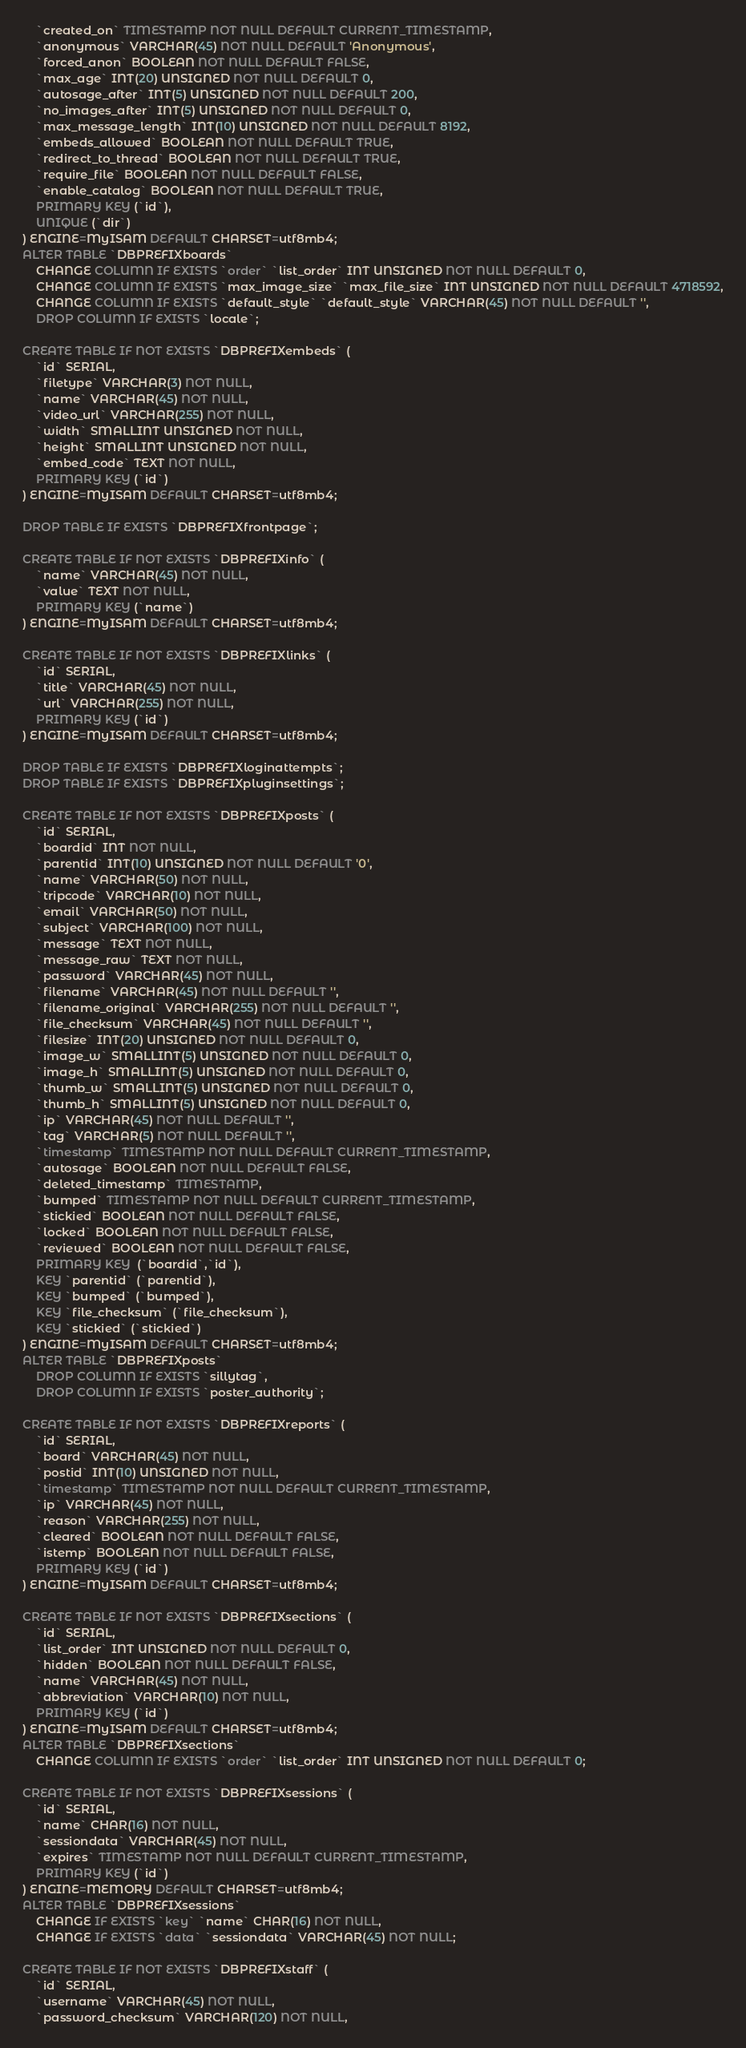Convert code to text. <code><loc_0><loc_0><loc_500><loc_500><_SQL_>	`created_on` TIMESTAMP NOT NULL DEFAULT CURRENT_TIMESTAMP,
	`anonymous` VARCHAR(45) NOT NULL DEFAULT 'Anonymous',
	`forced_anon` BOOLEAN NOT NULL DEFAULT FALSE,
	`max_age` INT(20) UNSIGNED NOT NULL DEFAULT 0,
	`autosage_after` INT(5) UNSIGNED NOT NULL DEFAULT 200,
	`no_images_after` INT(5) UNSIGNED NOT NULL DEFAULT 0,
	`max_message_length` INT(10) UNSIGNED NOT NULL DEFAULT 8192,
	`embeds_allowed` BOOLEAN NOT NULL DEFAULT TRUE,
	`redirect_to_thread` BOOLEAN NOT NULL DEFAULT TRUE,
	`require_file` BOOLEAN NOT NULL DEFAULT FALSE,
	`enable_catalog` BOOLEAN NOT NULL DEFAULT TRUE,
	PRIMARY KEY (`id`),
	UNIQUE (`dir`)
) ENGINE=MyISAM DEFAULT CHARSET=utf8mb4;
ALTER TABLE `DBPREFIXboards`
	CHANGE COLUMN IF EXISTS `order` `list_order` INT UNSIGNED NOT NULL DEFAULT 0,
	CHANGE COLUMN IF EXISTS `max_image_size` `max_file_size` INT UNSIGNED NOT NULL DEFAULT 4718592,
	CHANGE COLUMN IF EXISTS `default_style` `default_style` VARCHAR(45) NOT NULL DEFAULT '',
	DROP COLUMN IF EXISTS `locale`;

CREATE TABLE IF NOT EXISTS `DBPREFIXembeds` (
	`id` SERIAL,
	`filetype` VARCHAR(3) NOT NULL,
	`name` VARCHAR(45) NOT NULL,
	`video_url` VARCHAR(255) NOT NULL,
	`width` SMALLINT UNSIGNED NOT NULL,
	`height` SMALLINT UNSIGNED NOT NULL,
	`embed_code` TEXT NOT NULL,
	PRIMARY KEY (`id`)
) ENGINE=MyISAM DEFAULT CHARSET=utf8mb4;

DROP TABLE IF EXISTS `DBPREFIXfrontpage`;

CREATE TABLE IF NOT EXISTS `DBPREFIXinfo` (
	`name` VARCHAR(45) NOT NULL,
	`value` TEXT NOT NULL,
	PRIMARY KEY (`name`)
) ENGINE=MyISAM DEFAULT CHARSET=utf8mb4;

CREATE TABLE IF NOT EXISTS `DBPREFIXlinks` (
	`id` SERIAL,
	`title` VARCHAR(45) NOT NULL,
	`url` VARCHAR(255) NOT NULL,
	PRIMARY KEY (`id`)
) ENGINE=MyISAM DEFAULT CHARSET=utf8mb4;

DROP TABLE IF EXISTS `DBPREFIXloginattempts`;
DROP TABLE IF EXISTS `DBPREFIXpluginsettings`;

CREATE TABLE IF NOT EXISTS `DBPREFIXposts` (
	`id` SERIAL,
	`boardid` INT NOT NULL,
	`parentid` INT(10) UNSIGNED NOT NULL DEFAULT '0',
	`name` VARCHAR(50) NOT NULL,
	`tripcode` VARCHAR(10) NOT NULL,
	`email` VARCHAR(50) NOT NULL,
	`subject` VARCHAR(100) NOT NULL,
	`message` TEXT NOT NULL,
	`message_raw` TEXT NOT NULL,
	`password` VARCHAR(45) NOT NULL,
	`filename` VARCHAR(45) NOT NULL DEFAULT '',
	`filename_original` VARCHAR(255) NOT NULL DEFAULT '',
	`file_checksum` VARCHAR(45) NOT NULL DEFAULT '',
	`filesize` INT(20) UNSIGNED NOT NULL DEFAULT 0,
	`image_w` SMALLINT(5) UNSIGNED NOT NULL DEFAULT 0,
	`image_h` SMALLINT(5) UNSIGNED NOT NULL DEFAULT 0,
	`thumb_w` SMALLINT(5) UNSIGNED NOT NULL DEFAULT 0,
	`thumb_h` SMALLINT(5) UNSIGNED NOT NULL DEFAULT 0,
	`ip` VARCHAR(45) NOT NULL DEFAULT '',
	`tag` VARCHAR(5) NOT NULL DEFAULT '',
	`timestamp` TIMESTAMP NOT NULL DEFAULT CURRENT_TIMESTAMP,
	`autosage` BOOLEAN NOT NULL DEFAULT FALSE,
	`deleted_timestamp` TIMESTAMP,
	`bumped` TIMESTAMP NOT NULL DEFAULT CURRENT_TIMESTAMP,
	`stickied` BOOLEAN NOT NULL DEFAULT FALSE,
	`locked` BOOLEAN NOT NULL DEFAULT FALSE,
	`reviewed` BOOLEAN NOT NULL DEFAULT FALSE,
	PRIMARY KEY  (`boardid`,`id`),
	KEY `parentid` (`parentid`),
	KEY `bumped` (`bumped`),
	KEY `file_checksum` (`file_checksum`),
	KEY `stickied` (`stickied`)
) ENGINE=MyISAM DEFAULT CHARSET=utf8mb4;
ALTER TABLE `DBPREFIXposts`
	DROP COLUMN IF EXISTS `sillytag`,
	DROP COLUMN IF EXISTS `poster_authority`;

CREATE TABLE IF NOT EXISTS `DBPREFIXreports` (
	`id` SERIAL,
	`board` VARCHAR(45) NOT NULL,
	`postid` INT(10) UNSIGNED NOT NULL,
	`timestamp` TIMESTAMP NOT NULL DEFAULT CURRENT_TIMESTAMP,
	`ip` VARCHAR(45) NOT NULL,
	`reason` VARCHAR(255) NOT NULL,
	`cleared` BOOLEAN NOT NULL DEFAULT FALSE,
	`istemp` BOOLEAN NOT NULL DEFAULT FALSE,
	PRIMARY KEY (`id`)
) ENGINE=MyISAM DEFAULT CHARSET=utf8mb4;

CREATE TABLE IF NOT EXISTS `DBPREFIXsections` (
	`id` SERIAL,
	`list_order` INT UNSIGNED NOT NULL DEFAULT 0,
	`hidden` BOOLEAN NOT NULL DEFAULT FALSE,
	`name` VARCHAR(45) NOT NULL,
	`abbreviation` VARCHAR(10) NOT NULL,
	PRIMARY KEY (`id`)
) ENGINE=MyISAM DEFAULT CHARSET=utf8mb4;
ALTER TABLE `DBPREFIXsections`
	CHANGE COLUMN IF EXISTS `order` `list_order` INT UNSIGNED NOT NULL DEFAULT 0;

CREATE TABLE IF NOT EXISTS `DBPREFIXsessions` (
	`id` SERIAL,
	`name` CHAR(16) NOT NULL,
	`sessiondata` VARCHAR(45) NOT NULL,
	`expires` TIMESTAMP NOT NULL DEFAULT CURRENT_TIMESTAMP,
	PRIMARY KEY (`id`)
) ENGINE=MEMORY DEFAULT CHARSET=utf8mb4;
ALTER TABLE `DBPREFIXsessions`
	CHANGE IF EXISTS `key` `name` CHAR(16) NOT NULL,
	CHANGE IF EXISTS `data` `sessiondata` VARCHAR(45) NOT NULL;

CREATE TABLE IF NOT EXISTS `DBPREFIXstaff` (
	`id` SERIAL,
	`username` VARCHAR(45) NOT NULL,
	`password_checksum` VARCHAR(120) NOT NULL,</code> 